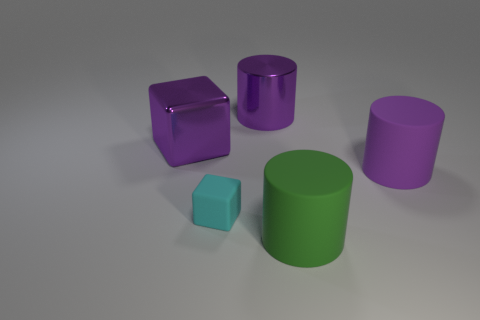Subtract all brown blocks. How many purple cylinders are left? 2 Subtract 1 cylinders. How many cylinders are left? 2 Add 1 big metal cylinders. How many objects exist? 6 Subtract all cylinders. How many objects are left? 2 Subtract 1 green cylinders. How many objects are left? 4 Subtract all tiny cyan matte things. Subtract all blue matte spheres. How many objects are left? 4 Add 1 small cyan things. How many small cyan things are left? 2 Add 3 large purple metallic cylinders. How many large purple metallic cylinders exist? 4 